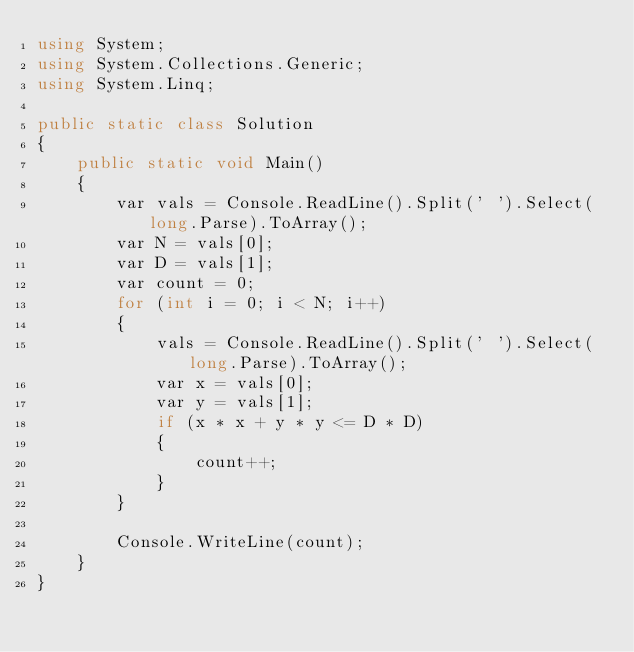<code> <loc_0><loc_0><loc_500><loc_500><_C#_>using System;
using System.Collections.Generic;
using System.Linq;

public static class Solution
{
    public static void Main()
    {
        var vals = Console.ReadLine().Split(' ').Select(long.Parse).ToArray();
        var N = vals[0];
        var D = vals[1];
        var count = 0;
        for (int i = 0; i < N; i++)
        {
            vals = Console.ReadLine().Split(' ').Select(long.Parse).ToArray();
            var x = vals[0];
            var y = vals[1];
            if (x * x + y * y <= D * D)
            {
                count++;
            }
        }

        Console.WriteLine(count);
    }
}</code> 